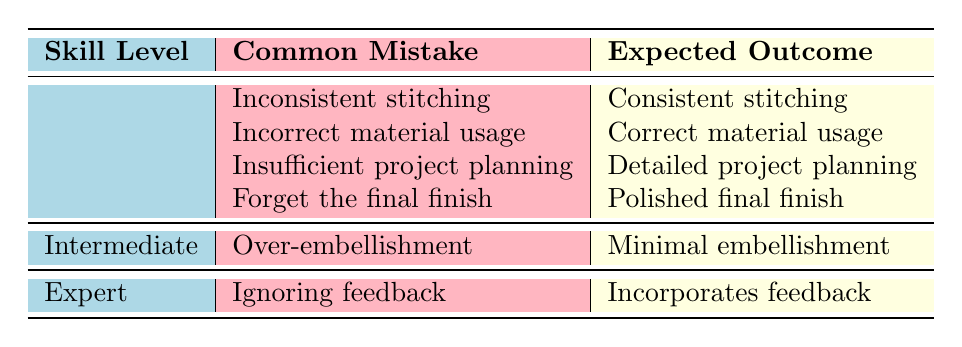What common mistake is associated with beginners regarding stitching? The table indicates that the common mistake associated with beginners regarding stitching is "Inconsistent stitching."
Answer: Inconsistent stitching What is the expected outcome for beginners who forget the final finish? The expected outcome for beginners who forget the final finish is "Polished final finish."
Answer: Polished final finish Are beginners expected to have detailed project planning? Yes, the table shows that detailed project planning is the expected outcome for beginners.
Answer: Yes What percentage of common mistakes listed are from beginners? There are 4 common mistakes for beginners out of a total of 6 mistakes, which calculates to 66.67%. (4/6)*100 = 66.67.
Answer: 66.67% What is the difference between the common mistake of an expert and that of an intermediate skill level in the table? The common mistake for experts is "Ignoring feedback," while for intermediates, it is "Over-embellishment." The difference in focus is that experts are expected to receive feedback, while intermediates struggle with excess decoration.
Answer: Different focus How many common mistakes are listed for intermediate skill level? The table lists one common mistake for the intermediate skill level, which is "Over-embellishment."
Answer: One Is "Incorrect material usage" a common mistake made by beginners? Yes, the table indicates that "Incorrect material usage" is indeed a common mistake for beginners.
Answer: Yes What is the expected outcome if a beginner makes insufficient project planning? The expected outcome is "Detailed project planning," indicating that their execution plan needs improvement.
Answer: Detailed project planning What common mistake do intermediate skill level artisans face, and what should they incorporate instead? Intermediate artisans face "Over-embellishment" as a common mistake, and they should instead aim for "Minimal embellishment." This highlights a need for restraint in decoration.
Answer: Minimal embellishment 